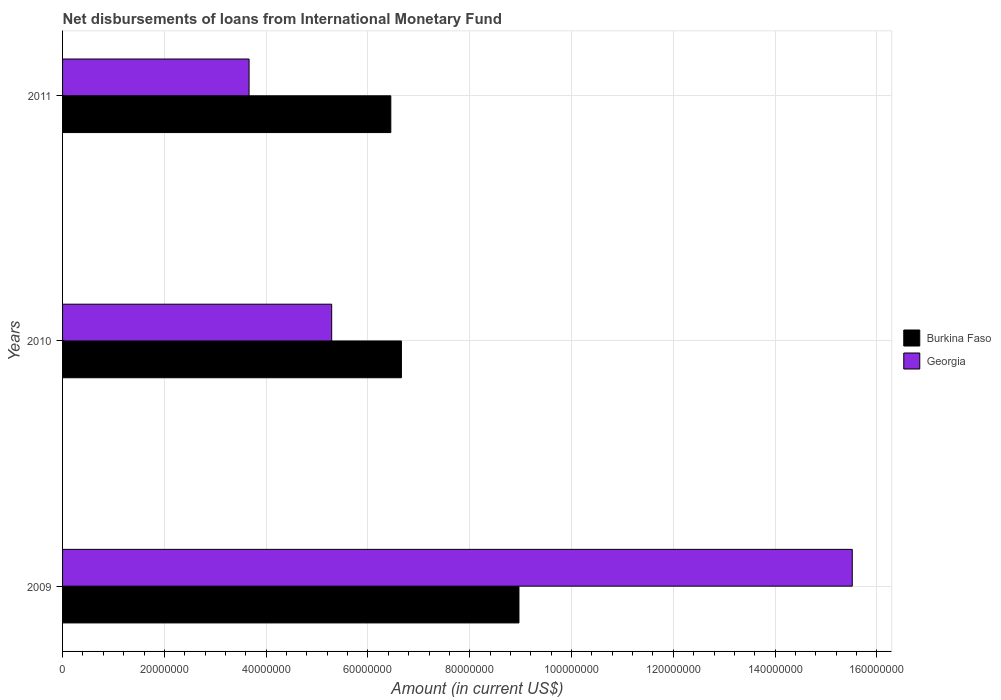How many different coloured bars are there?
Provide a short and direct response. 2. How many groups of bars are there?
Provide a short and direct response. 3. Are the number of bars per tick equal to the number of legend labels?
Your response must be concise. Yes. Are the number of bars on each tick of the Y-axis equal?
Your response must be concise. Yes. In how many cases, is the number of bars for a given year not equal to the number of legend labels?
Your response must be concise. 0. What is the amount of loans disbursed in Burkina Faso in 2009?
Your answer should be very brief. 8.97e+07. Across all years, what is the maximum amount of loans disbursed in Burkina Faso?
Make the answer very short. 8.97e+07. Across all years, what is the minimum amount of loans disbursed in Georgia?
Your response must be concise. 3.66e+07. In which year was the amount of loans disbursed in Burkina Faso maximum?
Provide a succinct answer. 2009. In which year was the amount of loans disbursed in Georgia minimum?
Ensure brevity in your answer.  2011. What is the total amount of loans disbursed in Burkina Faso in the graph?
Your response must be concise. 2.21e+08. What is the difference between the amount of loans disbursed in Georgia in 2009 and that in 2010?
Provide a short and direct response. 1.02e+08. What is the difference between the amount of loans disbursed in Burkina Faso in 2009 and the amount of loans disbursed in Georgia in 2011?
Your answer should be compact. 5.30e+07. What is the average amount of loans disbursed in Georgia per year?
Your answer should be compact. 8.16e+07. In the year 2010, what is the difference between the amount of loans disbursed in Georgia and amount of loans disbursed in Burkina Faso?
Ensure brevity in your answer.  -1.37e+07. In how many years, is the amount of loans disbursed in Burkina Faso greater than 128000000 US$?
Offer a very short reply. 0. What is the ratio of the amount of loans disbursed in Burkina Faso in 2009 to that in 2010?
Give a very brief answer. 1.35. Is the difference between the amount of loans disbursed in Georgia in 2009 and 2010 greater than the difference between the amount of loans disbursed in Burkina Faso in 2009 and 2010?
Offer a terse response. Yes. What is the difference between the highest and the second highest amount of loans disbursed in Georgia?
Offer a terse response. 1.02e+08. What is the difference between the highest and the lowest amount of loans disbursed in Georgia?
Make the answer very short. 1.19e+08. Is the sum of the amount of loans disbursed in Georgia in 2009 and 2010 greater than the maximum amount of loans disbursed in Burkina Faso across all years?
Ensure brevity in your answer.  Yes. What does the 2nd bar from the top in 2009 represents?
Your answer should be very brief. Burkina Faso. What does the 2nd bar from the bottom in 2009 represents?
Provide a succinct answer. Georgia. How many years are there in the graph?
Provide a succinct answer. 3. Are the values on the major ticks of X-axis written in scientific E-notation?
Give a very brief answer. No. Does the graph contain any zero values?
Your answer should be compact. No. Does the graph contain grids?
Provide a short and direct response. Yes. How many legend labels are there?
Ensure brevity in your answer.  2. What is the title of the graph?
Make the answer very short. Net disbursements of loans from International Monetary Fund. Does "Sweden" appear as one of the legend labels in the graph?
Offer a very short reply. No. What is the Amount (in current US$) of Burkina Faso in 2009?
Keep it short and to the point. 8.97e+07. What is the Amount (in current US$) in Georgia in 2009?
Provide a short and direct response. 1.55e+08. What is the Amount (in current US$) in Burkina Faso in 2010?
Make the answer very short. 6.66e+07. What is the Amount (in current US$) in Georgia in 2010?
Offer a terse response. 5.29e+07. What is the Amount (in current US$) of Burkina Faso in 2011?
Keep it short and to the point. 6.45e+07. What is the Amount (in current US$) of Georgia in 2011?
Provide a short and direct response. 3.66e+07. Across all years, what is the maximum Amount (in current US$) of Burkina Faso?
Make the answer very short. 8.97e+07. Across all years, what is the maximum Amount (in current US$) in Georgia?
Ensure brevity in your answer.  1.55e+08. Across all years, what is the minimum Amount (in current US$) in Burkina Faso?
Offer a terse response. 6.45e+07. Across all years, what is the minimum Amount (in current US$) in Georgia?
Offer a terse response. 3.66e+07. What is the total Amount (in current US$) of Burkina Faso in the graph?
Ensure brevity in your answer.  2.21e+08. What is the total Amount (in current US$) of Georgia in the graph?
Ensure brevity in your answer.  2.45e+08. What is the difference between the Amount (in current US$) of Burkina Faso in 2009 and that in 2010?
Offer a terse response. 2.31e+07. What is the difference between the Amount (in current US$) of Georgia in 2009 and that in 2010?
Offer a terse response. 1.02e+08. What is the difference between the Amount (in current US$) of Burkina Faso in 2009 and that in 2011?
Your response must be concise. 2.52e+07. What is the difference between the Amount (in current US$) of Georgia in 2009 and that in 2011?
Provide a short and direct response. 1.19e+08. What is the difference between the Amount (in current US$) in Burkina Faso in 2010 and that in 2011?
Offer a very short reply. 2.08e+06. What is the difference between the Amount (in current US$) in Georgia in 2010 and that in 2011?
Provide a succinct answer. 1.62e+07. What is the difference between the Amount (in current US$) in Burkina Faso in 2009 and the Amount (in current US$) in Georgia in 2010?
Offer a terse response. 3.68e+07. What is the difference between the Amount (in current US$) in Burkina Faso in 2009 and the Amount (in current US$) in Georgia in 2011?
Provide a succinct answer. 5.30e+07. What is the difference between the Amount (in current US$) in Burkina Faso in 2010 and the Amount (in current US$) in Georgia in 2011?
Give a very brief answer. 2.99e+07. What is the average Amount (in current US$) of Burkina Faso per year?
Provide a succinct answer. 7.36e+07. What is the average Amount (in current US$) of Georgia per year?
Provide a succinct answer. 8.16e+07. In the year 2009, what is the difference between the Amount (in current US$) of Burkina Faso and Amount (in current US$) of Georgia?
Give a very brief answer. -6.55e+07. In the year 2010, what is the difference between the Amount (in current US$) in Burkina Faso and Amount (in current US$) in Georgia?
Make the answer very short. 1.37e+07. In the year 2011, what is the difference between the Amount (in current US$) in Burkina Faso and Amount (in current US$) in Georgia?
Your answer should be very brief. 2.78e+07. What is the ratio of the Amount (in current US$) in Burkina Faso in 2009 to that in 2010?
Offer a very short reply. 1.35. What is the ratio of the Amount (in current US$) of Georgia in 2009 to that in 2010?
Provide a short and direct response. 2.93. What is the ratio of the Amount (in current US$) in Burkina Faso in 2009 to that in 2011?
Make the answer very short. 1.39. What is the ratio of the Amount (in current US$) of Georgia in 2009 to that in 2011?
Your answer should be compact. 4.23. What is the ratio of the Amount (in current US$) of Burkina Faso in 2010 to that in 2011?
Offer a terse response. 1.03. What is the ratio of the Amount (in current US$) in Georgia in 2010 to that in 2011?
Provide a short and direct response. 1.44. What is the difference between the highest and the second highest Amount (in current US$) of Burkina Faso?
Give a very brief answer. 2.31e+07. What is the difference between the highest and the second highest Amount (in current US$) of Georgia?
Your answer should be compact. 1.02e+08. What is the difference between the highest and the lowest Amount (in current US$) of Burkina Faso?
Provide a short and direct response. 2.52e+07. What is the difference between the highest and the lowest Amount (in current US$) of Georgia?
Keep it short and to the point. 1.19e+08. 